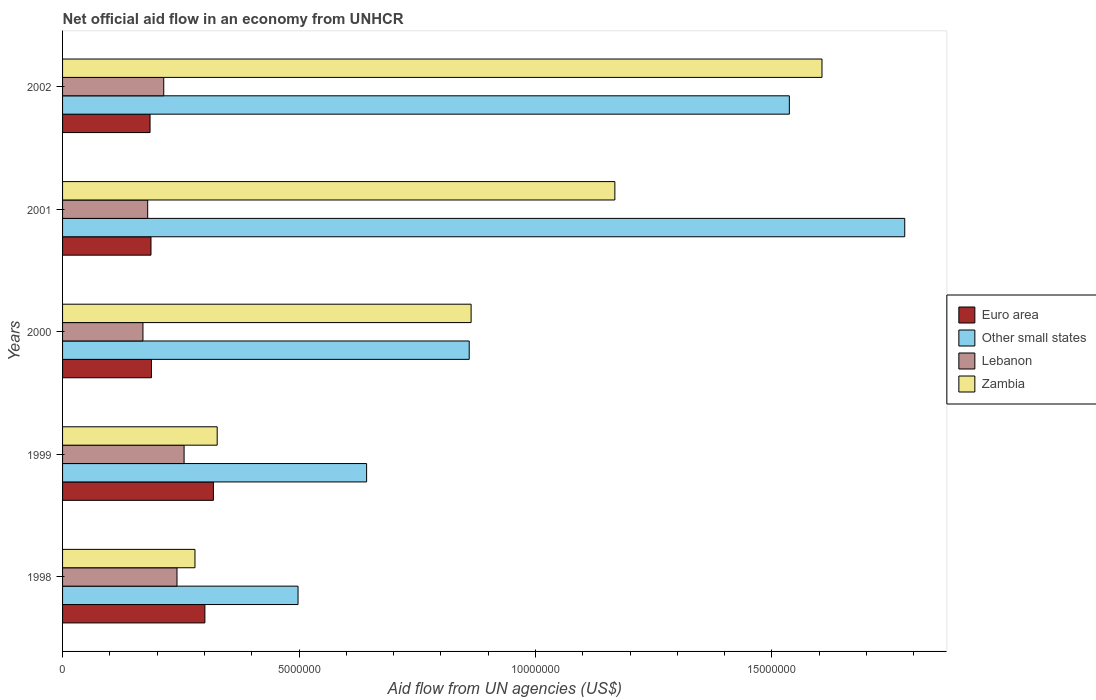Are the number of bars on each tick of the Y-axis equal?
Keep it short and to the point. Yes. How many bars are there on the 1st tick from the top?
Your answer should be compact. 4. How many bars are there on the 5th tick from the bottom?
Provide a short and direct response. 4. What is the label of the 5th group of bars from the top?
Offer a very short reply. 1998. In how many cases, is the number of bars for a given year not equal to the number of legend labels?
Offer a terse response. 0. What is the net official aid flow in Zambia in 2000?
Keep it short and to the point. 8.64e+06. Across all years, what is the maximum net official aid flow in Euro area?
Your response must be concise. 3.19e+06. Across all years, what is the minimum net official aid flow in Euro area?
Make the answer very short. 1.85e+06. In which year was the net official aid flow in Euro area maximum?
Provide a short and direct response. 1999. What is the total net official aid flow in Lebanon in the graph?
Make the answer very short. 1.06e+07. What is the difference between the net official aid flow in Zambia in 2001 and the net official aid flow in Lebanon in 1999?
Your response must be concise. 9.11e+06. What is the average net official aid flow in Zambia per year?
Ensure brevity in your answer.  8.49e+06. In the year 1999, what is the difference between the net official aid flow in Other small states and net official aid flow in Zambia?
Your answer should be compact. 3.16e+06. What is the ratio of the net official aid flow in Other small states in 2000 to that in 2001?
Keep it short and to the point. 0.48. Is the net official aid flow in Euro area in 2000 less than that in 2001?
Your answer should be compact. No. Is the difference between the net official aid flow in Other small states in 1999 and 2001 greater than the difference between the net official aid flow in Zambia in 1999 and 2001?
Provide a short and direct response. No. What is the difference between the highest and the second highest net official aid flow in Lebanon?
Your response must be concise. 1.50e+05. What is the difference between the highest and the lowest net official aid flow in Other small states?
Your answer should be compact. 1.28e+07. In how many years, is the net official aid flow in Other small states greater than the average net official aid flow in Other small states taken over all years?
Ensure brevity in your answer.  2. Is the sum of the net official aid flow in Euro area in 2000 and 2001 greater than the maximum net official aid flow in Zambia across all years?
Offer a terse response. No. Is it the case that in every year, the sum of the net official aid flow in Zambia and net official aid flow in Other small states is greater than the sum of net official aid flow in Lebanon and net official aid flow in Euro area?
Provide a succinct answer. No. What does the 1st bar from the top in 2002 represents?
Provide a short and direct response. Zambia. What does the 3rd bar from the bottom in 2001 represents?
Provide a short and direct response. Lebanon. Are all the bars in the graph horizontal?
Your response must be concise. Yes. What is the difference between two consecutive major ticks on the X-axis?
Give a very brief answer. 5.00e+06. Are the values on the major ticks of X-axis written in scientific E-notation?
Keep it short and to the point. No. Does the graph contain any zero values?
Provide a short and direct response. No. Does the graph contain grids?
Keep it short and to the point. No. Where does the legend appear in the graph?
Provide a short and direct response. Center right. How are the legend labels stacked?
Keep it short and to the point. Vertical. What is the title of the graph?
Offer a terse response. Net official aid flow in an economy from UNHCR. What is the label or title of the X-axis?
Give a very brief answer. Aid flow from UN agencies (US$). What is the label or title of the Y-axis?
Provide a short and direct response. Years. What is the Aid flow from UN agencies (US$) in Euro area in 1998?
Your answer should be very brief. 3.01e+06. What is the Aid flow from UN agencies (US$) in Other small states in 1998?
Make the answer very short. 4.98e+06. What is the Aid flow from UN agencies (US$) of Lebanon in 1998?
Offer a very short reply. 2.42e+06. What is the Aid flow from UN agencies (US$) in Zambia in 1998?
Your answer should be very brief. 2.80e+06. What is the Aid flow from UN agencies (US$) of Euro area in 1999?
Your answer should be very brief. 3.19e+06. What is the Aid flow from UN agencies (US$) in Other small states in 1999?
Give a very brief answer. 6.43e+06. What is the Aid flow from UN agencies (US$) of Lebanon in 1999?
Offer a very short reply. 2.57e+06. What is the Aid flow from UN agencies (US$) in Zambia in 1999?
Give a very brief answer. 3.27e+06. What is the Aid flow from UN agencies (US$) of Euro area in 2000?
Ensure brevity in your answer.  1.88e+06. What is the Aid flow from UN agencies (US$) in Other small states in 2000?
Offer a very short reply. 8.60e+06. What is the Aid flow from UN agencies (US$) in Lebanon in 2000?
Provide a succinct answer. 1.70e+06. What is the Aid flow from UN agencies (US$) in Zambia in 2000?
Keep it short and to the point. 8.64e+06. What is the Aid flow from UN agencies (US$) in Euro area in 2001?
Ensure brevity in your answer.  1.87e+06. What is the Aid flow from UN agencies (US$) of Other small states in 2001?
Provide a succinct answer. 1.78e+07. What is the Aid flow from UN agencies (US$) of Lebanon in 2001?
Your answer should be compact. 1.80e+06. What is the Aid flow from UN agencies (US$) in Zambia in 2001?
Provide a succinct answer. 1.17e+07. What is the Aid flow from UN agencies (US$) in Euro area in 2002?
Keep it short and to the point. 1.85e+06. What is the Aid flow from UN agencies (US$) in Other small states in 2002?
Your answer should be very brief. 1.54e+07. What is the Aid flow from UN agencies (US$) in Lebanon in 2002?
Your answer should be compact. 2.14e+06. What is the Aid flow from UN agencies (US$) of Zambia in 2002?
Offer a terse response. 1.61e+07. Across all years, what is the maximum Aid flow from UN agencies (US$) of Euro area?
Provide a succinct answer. 3.19e+06. Across all years, what is the maximum Aid flow from UN agencies (US$) of Other small states?
Your answer should be compact. 1.78e+07. Across all years, what is the maximum Aid flow from UN agencies (US$) in Lebanon?
Make the answer very short. 2.57e+06. Across all years, what is the maximum Aid flow from UN agencies (US$) in Zambia?
Ensure brevity in your answer.  1.61e+07. Across all years, what is the minimum Aid flow from UN agencies (US$) in Euro area?
Your answer should be very brief. 1.85e+06. Across all years, what is the minimum Aid flow from UN agencies (US$) in Other small states?
Your answer should be very brief. 4.98e+06. Across all years, what is the minimum Aid flow from UN agencies (US$) of Lebanon?
Give a very brief answer. 1.70e+06. Across all years, what is the minimum Aid flow from UN agencies (US$) in Zambia?
Make the answer very short. 2.80e+06. What is the total Aid flow from UN agencies (US$) in Euro area in the graph?
Make the answer very short. 1.18e+07. What is the total Aid flow from UN agencies (US$) of Other small states in the graph?
Offer a terse response. 5.32e+07. What is the total Aid flow from UN agencies (US$) of Lebanon in the graph?
Your answer should be compact. 1.06e+07. What is the total Aid flow from UN agencies (US$) of Zambia in the graph?
Offer a very short reply. 4.24e+07. What is the difference between the Aid flow from UN agencies (US$) of Euro area in 1998 and that in 1999?
Provide a short and direct response. -1.80e+05. What is the difference between the Aid flow from UN agencies (US$) of Other small states in 1998 and that in 1999?
Ensure brevity in your answer.  -1.45e+06. What is the difference between the Aid flow from UN agencies (US$) of Lebanon in 1998 and that in 1999?
Provide a short and direct response. -1.50e+05. What is the difference between the Aid flow from UN agencies (US$) in Zambia in 1998 and that in 1999?
Your answer should be compact. -4.70e+05. What is the difference between the Aid flow from UN agencies (US$) of Euro area in 1998 and that in 2000?
Offer a very short reply. 1.13e+06. What is the difference between the Aid flow from UN agencies (US$) in Other small states in 1998 and that in 2000?
Keep it short and to the point. -3.62e+06. What is the difference between the Aid flow from UN agencies (US$) in Lebanon in 1998 and that in 2000?
Your answer should be very brief. 7.20e+05. What is the difference between the Aid flow from UN agencies (US$) in Zambia in 1998 and that in 2000?
Offer a very short reply. -5.84e+06. What is the difference between the Aid flow from UN agencies (US$) in Euro area in 1998 and that in 2001?
Offer a terse response. 1.14e+06. What is the difference between the Aid flow from UN agencies (US$) of Other small states in 1998 and that in 2001?
Your response must be concise. -1.28e+07. What is the difference between the Aid flow from UN agencies (US$) of Lebanon in 1998 and that in 2001?
Your answer should be very brief. 6.20e+05. What is the difference between the Aid flow from UN agencies (US$) in Zambia in 1998 and that in 2001?
Give a very brief answer. -8.88e+06. What is the difference between the Aid flow from UN agencies (US$) in Euro area in 1998 and that in 2002?
Offer a very short reply. 1.16e+06. What is the difference between the Aid flow from UN agencies (US$) in Other small states in 1998 and that in 2002?
Provide a short and direct response. -1.04e+07. What is the difference between the Aid flow from UN agencies (US$) of Zambia in 1998 and that in 2002?
Offer a very short reply. -1.33e+07. What is the difference between the Aid flow from UN agencies (US$) of Euro area in 1999 and that in 2000?
Offer a very short reply. 1.31e+06. What is the difference between the Aid flow from UN agencies (US$) of Other small states in 1999 and that in 2000?
Keep it short and to the point. -2.17e+06. What is the difference between the Aid flow from UN agencies (US$) of Lebanon in 1999 and that in 2000?
Provide a short and direct response. 8.70e+05. What is the difference between the Aid flow from UN agencies (US$) in Zambia in 1999 and that in 2000?
Your response must be concise. -5.37e+06. What is the difference between the Aid flow from UN agencies (US$) of Euro area in 1999 and that in 2001?
Offer a very short reply. 1.32e+06. What is the difference between the Aid flow from UN agencies (US$) in Other small states in 1999 and that in 2001?
Provide a succinct answer. -1.14e+07. What is the difference between the Aid flow from UN agencies (US$) in Lebanon in 1999 and that in 2001?
Keep it short and to the point. 7.70e+05. What is the difference between the Aid flow from UN agencies (US$) of Zambia in 1999 and that in 2001?
Provide a succinct answer. -8.41e+06. What is the difference between the Aid flow from UN agencies (US$) in Euro area in 1999 and that in 2002?
Make the answer very short. 1.34e+06. What is the difference between the Aid flow from UN agencies (US$) of Other small states in 1999 and that in 2002?
Give a very brief answer. -8.94e+06. What is the difference between the Aid flow from UN agencies (US$) of Zambia in 1999 and that in 2002?
Your answer should be very brief. -1.28e+07. What is the difference between the Aid flow from UN agencies (US$) of Other small states in 2000 and that in 2001?
Give a very brief answer. -9.21e+06. What is the difference between the Aid flow from UN agencies (US$) in Lebanon in 2000 and that in 2001?
Give a very brief answer. -1.00e+05. What is the difference between the Aid flow from UN agencies (US$) of Zambia in 2000 and that in 2001?
Your answer should be compact. -3.04e+06. What is the difference between the Aid flow from UN agencies (US$) in Other small states in 2000 and that in 2002?
Your answer should be very brief. -6.77e+06. What is the difference between the Aid flow from UN agencies (US$) of Lebanon in 2000 and that in 2002?
Provide a short and direct response. -4.40e+05. What is the difference between the Aid flow from UN agencies (US$) in Zambia in 2000 and that in 2002?
Offer a terse response. -7.42e+06. What is the difference between the Aid flow from UN agencies (US$) in Other small states in 2001 and that in 2002?
Give a very brief answer. 2.44e+06. What is the difference between the Aid flow from UN agencies (US$) of Zambia in 2001 and that in 2002?
Your answer should be compact. -4.38e+06. What is the difference between the Aid flow from UN agencies (US$) in Euro area in 1998 and the Aid flow from UN agencies (US$) in Other small states in 1999?
Give a very brief answer. -3.42e+06. What is the difference between the Aid flow from UN agencies (US$) of Other small states in 1998 and the Aid flow from UN agencies (US$) of Lebanon in 1999?
Give a very brief answer. 2.41e+06. What is the difference between the Aid flow from UN agencies (US$) in Other small states in 1998 and the Aid flow from UN agencies (US$) in Zambia in 1999?
Provide a succinct answer. 1.71e+06. What is the difference between the Aid flow from UN agencies (US$) of Lebanon in 1998 and the Aid flow from UN agencies (US$) of Zambia in 1999?
Keep it short and to the point. -8.50e+05. What is the difference between the Aid flow from UN agencies (US$) in Euro area in 1998 and the Aid flow from UN agencies (US$) in Other small states in 2000?
Offer a terse response. -5.59e+06. What is the difference between the Aid flow from UN agencies (US$) of Euro area in 1998 and the Aid flow from UN agencies (US$) of Lebanon in 2000?
Give a very brief answer. 1.31e+06. What is the difference between the Aid flow from UN agencies (US$) of Euro area in 1998 and the Aid flow from UN agencies (US$) of Zambia in 2000?
Ensure brevity in your answer.  -5.63e+06. What is the difference between the Aid flow from UN agencies (US$) of Other small states in 1998 and the Aid flow from UN agencies (US$) of Lebanon in 2000?
Provide a short and direct response. 3.28e+06. What is the difference between the Aid flow from UN agencies (US$) of Other small states in 1998 and the Aid flow from UN agencies (US$) of Zambia in 2000?
Offer a terse response. -3.66e+06. What is the difference between the Aid flow from UN agencies (US$) of Lebanon in 1998 and the Aid flow from UN agencies (US$) of Zambia in 2000?
Your answer should be very brief. -6.22e+06. What is the difference between the Aid flow from UN agencies (US$) of Euro area in 1998 and the Aid flow from UN agencies (US$) of Other small states in 2001?
Keep it short and to the point. -1.48e+07. What is the difference between the Aid flow from UN agencies (US$) of Euro area in 1998 and the Aid flow from UN agencies (US$) of Lebanon in 2001?
Make the answer very short. 1.21e+06. What is the difference between the Aid flow from UN agencies (US$) in Euro area in 1998 and the Aid flow from UN agencies (US$) in Zambia in 2001?
Make the answer very short. -8.67e+06. What is the difference between the Aid flow from UN agencies (US$) of Other small states in 1998 and the Aid flow from UN agencies (US$) of Lebanon in 2001?
Provide a succinct answer. 3.18e+06. What is the difference between the Aid flow from UN agencies (US$) of Other small states in 1998 and the Aid flow from UN agencies (US$) of Zambia in 2001?
Your answer should be compact. -6.70e+06. What is the difference between the Aid flow from UN agencies (US$) in Lebanon in 1998 and the Aid flow from UN agencies (US$) in Zambia in 2001?
Ensure brevity in your answer.  -9.26e+06. What is the difference between the Aid flow from UN agencies (US$) of Euro area in 1998 and the Aid flow from UN agencies (US$) of Other small states in 2002?
Your answer should be compact. -1.24e+07. What is the difference between the Aid flow from UN agencies (US$) in Euro area in 1998 and the Aid flow from UN agencies (US$) in Lebanon in 2002?
Offer a very short reply. 8.70e+05. What is the difference between the Aid flow from UN agencies (US$) in Euro area in 1998 and the Aid flow from UN agencies (US$) in Zambia in 2002?
Provide a succinct answer. -1.30e+07. What is the difference between the Aid flow from UN agencies (US$) in Other small states in 1998 and the Aid flow from UN agencies (US$) in Lebanon in 2002?
Your answer should be compact. 2.84e+06. What is the difference between the Aid flow from UN agencies (US$) of Other small states in 1998 and the Aid flow from UN agencies (US$) of Zambia in 2002?
Give a very brief answer. -1.11e+07. What is the difference between the Aid flow from UN agencies (US$) in Lebanon in 1998 and the Aid flow from UN agencies (US$) in Zambia in 2002?
Give a very brief answer. -1.36e+07. What is the difference between the Aid flow from UN agencies (US$) in Euro area in 1999 and the Aid flow from UN agencies (US$) in Other small states in 2000?
Keep it short and to the point. -5.41e+06. What is the difference between the Aid flow from UN agencies (US$) of Euro area in 1999 and the Aid flow from UN agencies (US$) of Lebanon in 2000?
Offer a terse response. 1.49e+06. What is the difference between the Aid flow from UN agencies (US$) of Euro area in 1999 and the Aid flow from UN agencies (US$) of Zambia in 2000?
Keep it short and to the point. -5.45e+06. What is the difference between the Aid flow from UN agencies (US$) in Other small states in 1999 and the Aid flow from UN agencies (US$) in Lebanon in 2000?
Your answer should be compact. 4.73e+06. What is the difference between the Aid flow from UN agencies (US$) of Other small states in 1999 and the Aid flow from UN agencies (US$) of Zambia in 2000?
Your response must be concise. -2.21e+06. What is the difference between the Aid flow from UN agencies (US$) of Lebanon in 1999 and the Aid flow from UN agencies (US$) of Zambia in 2000?
Provide a succinct answer. -6.07e+06. What is the difference between the Aid flow from UN agencies (US$) of Euro area in 1999 and the Aid flow from UN agencies (US$) of Other small states in 2001?
Offer a very short reply. -1.46e+07. What is the difference between the Aid flow from UN agencies (US$) in Euro area in 1999 and the Aid flow from UN agencies (US$) in Lebanon in 2001?
Keep it short and to the point. 1.39e+06. What is the difference between the Aid flow from UN agencies (US$) of Euro area in 1999 and the Aid flow from UN agencies (US$) of Zambia in 2001?
Offer a terse response. -8.49e+06. What is the difference between the Aid flow from UN agencies (US$) in Other small states in 1999 and the Aid flow from UN agencies (US$) in Lebanon in 2001?
Your answer should be compact. 4.63e+06. What is the difference between the Aid flow from UN agencies (US$) in Other small states in 1999 and the Aid flow from UN agencies (US$) in Zambia in 2001?
Offer a very short reply. -5.25e+06. What is the difference between the Aid flow from UN agencies (US$) of Lebanon in 1999 and the Aid flow from UN agencies (US$) of Zambia in 2001?
Your response must be concise. -9.11e+06. What is the difference between the Aid flow from UN agencies (US$) in Euro area in 1999 and the Aid flow from UN agencies (US$) in Other small states in 2002?
Your response must be concise. -1.22e+07. What is the difference between the Aid flow from UN agencies (US$) in Euro area in 1999 and the Aid flow from UN agencies (US$) in Lebanon in 2002?
Offer a very short reply. 1.05e+06. What is the difference between the Aid flow from UN agencies (US$) in Euro area in 1999 and the Aid flow from UN agencies (US$) in Zambia in 2002?
Offer a very short reply. -1.29e+07. What is the difference between the Aid flow from UN agencies (US$) of Other small states in 1999 and the Aid flow from UN agencies (US$) of Lebanon in 2002?
Give a very brief answer. 4.29e+06. What is the difference between the Aid flow from UN agencies (US$) in Other small states in 1999 and the Aid flow from UN agencies (US$) in Zambia in 2002?
Offer a very short reply. -9.63e+06. What is the difference between the Aid flow from UN agencies (US$) of Lebanon in 1999 and the Aid flow from UN agencies (US$) of Zambia in 2002?
Keep it short and to the point. -1.35e+07. What is the difference between the Aid flow from UN agencies (US$) of Euro area in 2000 and the Aid flow from UN agencies (US$) of Other small states in 2001?
Your response must be concise. -1.59e+07. What is the difference between the Aid flow from UN agencies (US$) in Euro area in 2000 and the Aid flow from UN agencies (US$) in Zambia in 2001?
Offer a very short reply. -9.80e+06. What is the difference between the Aid flow from UN agencies (US$) of Other small states in 2000 and the Aid flow from UN agencies (US$) of Lebanon in 2001?
Ensure brevity in your answer.  6.80e+06. What is the difference between the Aid flow from UN agencies (US$) in Other small states in 2000 and the Aid flow from UN agencies (US$) in Zambia in 2001?
Provide a short and direct response. -3.08e+06. What is the difference between the Aid flow from UN agencies (US$) of Lebanon in 2000 and the Aid flow from UN agencies (US$) of Zambia in 2001?
Your response must be concise. -9.98e+06. What is the difference between the Aid flow from UN agencies (US$) of Euro area in 2000 and the Aid flow from UN agencies (US$) of Other small states in 2002?
Your answer should be very brief. -1.35e+07. What is the difference between the Aid flow from UN agencies (US$) in Euro area in 2000 and the Aid flow from UN agencies (US$) in Zambia in 2002?
Ensure brevity in your answer.  -1.42e+07. What is the difference between the Aid flow from UN agencies (US$) of Other small states in 2000 and the Aid flow from UN agencies (US$) of Lebanon in 2002?
Make the answer very short. 6.46e+06. What is the difference between the Aid flow from UN agencies (US$) in Other small states in 2000 and the Aid flow from UN agencies (US$) in Zambia in 2002?
Offer a terse response. -7.46e+06. What is the difference between the Aid flow from UN agencies (US$) in Lebanon in 2000 and the Aid flow from UN agencies (US$) in Zambia in 2002?
Give a very brief answer. -1.44e+07. What is the difference between the Aid flow from UN agencies (US$) in Euro area in 2001 and the Aid flow from UN agencies (US$) in Other small states in 2002?
Provide a succinct answer. -1.35e+07. What is the difference between the Aid flow from UN agencies (US$) in Euro area in 2001 and the Aid flow from UN agencies (US$) in Zambia in 2002?
Your answer should be very brief. -1.42e+07. What is the difference between the Aid flow from UN agencies (US$) of Other small states in 2001 and the Aid flow from UN agencies (US$) of Lebanon in 2002?
Your response must be concise. 1.57e+07. What is the difference between the Aid flow from UN agencies (US$) in Other small states in 2001 and the Aid flow from UN agencies (US$) in Zambia in 2002?
Your answer should be very brief. 1.75e+06. What is the difference between the Aid flow from UN agencies (US$) in Lebanon in 2001 and the Aid flow from UN agencies (US$) in Zambia in 2002?
Make the answer very short. -1.43e+07. What is the average Aid flow from UN agencies (US$) of Euro area per year?
Ensure brevity in your answer.  2.36e+06. What is the average Aid flow from UN agencies (US$) in Other small states per year?
Provide a succinct answer. 1.06e+07. What is the average Aid flow from UN agencies (US$) in Lebanon per year?
Give a very brief answer. 2.13e+06. What is the average Aid flow from UN agencies (US$) in Zambia per year?
Your answer should be very brief. 8.49e+06. In the year 1998, what is the difference between the Aid flow from UN agencies (US$) in Euro area and Aid flow from UN agencies (US$) in Other small states?
Your response must be concise. -1.97e+06. In the year 1998, what is the difference between the Aid flow from UN agencies (US$) in Euro area and Aid flow from UN agencies (US$) in Lebanon?
Provide a short and direct response. 5.90e+05. In the year 1998, what is the difference between the Aid flow from UN agencies (US$) of Euro area and Aid flow from UN agencies (US$) of Zambia?
Offer a terse response. 2.10e+05. In the year 1998, what is the difference between the Aid flow from UN agencies (US$) in Other small states and Aid flow from UN agencies (US$) in Lebanon?
Your answer should be compact. 2.56e+06. In the year 1998, what is the difference between the Aid flow from UN agencies (US$) in Other small states and Aid flow from UN agencies (US$) in Zambia?
Your answer should be compact. 2.18e+06. In the year 1998, what is the difference between the Aid flow from UN agencies (US$) of Lebanon and Aid flow from UN agencies (US$) of Zambia?
Provide a short and direct response. -3.80e+05. In the year 1999, what is the difference between the Aid flow from UN agencies (US$) of Euro area and Aid flow from UN agencies (US$) of Other small states?
Keep it short and to the point. -3.24e+06. In the year 1999, what is the difference between the Aid flow from UN agencies (US$) in Euro area and Aid flow from UN agencies (US$) in Lebanon?
Ensure brevity in your answer.  6.20e+05. In the year 1999, what is the difference between the Aid flow from UN agencies (US$) of Euro area and Aid flow from UN agencies (US$) of Zambia?
Offer a very short reply. -8.00e+04. In the year 1999, what is the difference between the Aid flow from UN agencies (US$) in Other small states and Aid flow from UN agencies (US$) in Lebanon?
Your response must be concise. 3.86e+06. In the year 1999, what is the difference between the Aid flow from UN agencies (US$) of Other small states and Aid flow from UN agencies (US$) of Zambia?
Offer a very short reply. 3.16e+06. In the year 1999, what is the difference between the Aid flow from UN agencies (US$) of Lebanon and Aid flow from UN agencies (US$) of Zambia?
Offer a very short reply. -7.00e+05. In the year 2000, what is the difference between the Aid flow from UN agencies (US$) of Euro area and Aid flow from UN agencies (US$) of Other small states?
Offer a very short reply. -6.72e+06. In the year 2000, what is the difference between the Aid flow from UN agencies (US$) in Euro area and Aid flow from UN agencies (US$) in Zambia?
Keep it short and to the point. -6.76e+06. In the year 2000, what is the difference between the Aid flow from UN agencies (US$) in Other small states and Aid flow from UN agencies (US$) in Lebanon?
Your answer should be very brief. 6.90e+06. In the year 2000, what is the difference between the Aid flow from UN agencies (US$) in Other small states and Aid flow from UN agencies (US$) in Zambia?
Provide a succinct answer. -4.00e+04. In the year 2000, what is the difference between the Aid flow from UN agencies (US$) of Lebanon and Aid flow from UN agencies (US$) of Zambia?
Provide a succinct answer. -6.94e+06. In the year 2001, what is the difference between the Aid flow from UN agencies (US$) of Euro area and Aid flow from UN agencies (US$) of Other small states?
Ensure brevity in your answer.  -1.59e+07. In the year 2001, what is the difference between the Aid flow from UN agencies (US$) in Euro area and Aid flow from UN agencies (US$) in Lebanon?
Your response must be concise. 7.00e+04. In the year 2001, what is the difference between the Aid flow from UN agencies (US$) of Euro area and Aid flow from UN agencies (US$) of Zambia?
Offer a very short reply. -9.81e+06. In the year 2001, what is the difference between the Aid flow from UN agencies (US$) of Other small states and Aid flow from UN agencies (US$) of Lebanon?
Offer a very short reply. 1.60e+07. In the year 2001, what is the difference between the Aid flow from UN agencies (US$) of Other small states and Aid flow from UN agencies (US$) of Zambia?
Make the answer very short. 6.13e+06. In the year 2001, what is the difference between the Aid flow from UN agencies (US$) in Lebanon and Aid flow from UN agencies (US$) in Zambia?
Your response must be concise. -9.88e+06. In the year 2002, what is the difference between the Aid flow from UN agencies (US$) of Euro area and Aid flow from UN agencies (US$) of Other small states?
Your response must be concise. -1.35e+07. In the year 2002, what is the difference between the Aid flow from UN agencies (US$) of Euro area and Aid flow from UN agencies (US$) of Zambia?
Provide a short and direct response. -1.42e+07. In the year 2002, what is the difference between the Aid flow from UN agencies (US$) of Other small states and Aid flow from UN agencies (US$) of Lebanon?
Provide a short and direct response. 1.32e+07. In the year 2002, what is the difference between the Aid flow from UN agencies (US$) of Other small states and Aid flow from UN agencies (US$) of Zambia?
Provide a short and direct response. -6.90e+05. In the year 2002, what is the difference between the Aid flow from UN agencies (US$) of Lebanon and Aid flow from UN agencies (US$) of Zambia?
Provide a short and direct response. -1.39e+07. What is the ratio of the Aid flow from UN agencies (US$) of Euro area in 1998 to that in 1999?
Make the answer very short. 0.94. What is the ratio of the Aid flow from UN agencies (US$) in Other small states in 1998 to that in 1999?
Your response must be concise. 0.77. What is the ratio of the Aid flow from UN agencies (US$) of Lebanon in 1998 to that in 1999?
Provide a short and direct response. 0.94. What is the ratio of the Aid flow from UN agencies (US$) of Zambia in 1998 to that in 1999?
Offer a very short reply. 0.86. What is the ratio of the Aid flow from UN agencies (US$) of Euro area in 1998 to that in 2000?
Keep it short and to the point. 1.6. What is the ratio of the Aid flow from UN agencies (US$) in Other small states in 1998 to that in 2000?
Offer a very short reply. 0.58. What is the ratio of the Aid flow from UN agencies (US$) of Lebanon in 1998 to that in 2000?
Give a very brief answer. 1.42. What is the ratio of the Aid flow from UN agencies (US$) of Zambia in 1998 to that in 2000?
Your response must be concise. 0.32. What is the ratio of the Aid flow from UN agencies (US$) in Euro area in 1998 to that in 2001?
Give a very brief answer. 1.61. What is the ratio of the Aid flow from UN agencies (US$) of Other small states in 1998 to that in 2001?
Offer a terse response. 0.28. What is the ratio of the Aid flow from UN agencies (US$) in Lebanon in 1998 to that in 2001?
Offer a very short reply. 1.34. What is the ratio of the Aid flow from UN agencies (US$) of Zambia in 1998 to that in 2001?
Your answer should be compact. 0.24. What is the ratio of the Aid flow from UN agencies (US$) in Euro area in 1998 to that in 2002?
Your answer should be compact. 1.63. What is the ratio of the Aid flow from UN agencies (US$) in Other small states in 1998 to that in 2002?
Your response must be concise. 0.32. What is the ratio of the Aid flow from UN agencies (US$) of Lebanon in 1998 to that in 2002?
Your answer should be very brief. 1.13. What is the ratio of the Aid flow from UN agencies (US$) in Zambia in 1998 to that in 2002?
Your answer should be very brief. 0.17. What is the ratio of the Aid flow from UN agencies (US$) of Euro area in 1999 to that in 2000?
Your response must be concise. 1.7. What is the ratio of the Aid flow from UN agencies (US$) in Other small states in 1999 to that in 2000?
Keep it short and to the point. 0.75. What is the ratio of the Aid flow from UN agencies (US$) of Lebanon in 1999 to that in 2000?
Give a very brief answer. 1.51. What is the ratio of the Aid flow from UN agencies (US$) of Zambia in 1999 to that in 2000?
Keep it short and to the point. 0.38. What is the ratio of the Aid flow from UN agencies (US$) in Euro area in 1999 to that in 2001?
Your response must be concise. 1.71. What is the ratio of the Aid flow from UN agencies (US$) of Other small states in 1999 to that in 2001?
Your response must be concise. 0.36. What is the ratio of the Aid flow from UN agencies (US$) of Lebanon in 1999 to that in 2001?
Ensure brevity in your answer.  1.43. What is the ratio of the Aid flow from UN agencies (US$) in Zambia in 1999 to that in 2001?
Keep it short and to the point. 0.28. What is the ratio of the Aid flow from UN agencies (US$) of Euro area in 1999 to that in 2002?
Keep it short and to the point. 1.72. What is the ratio of the Aid flow from UN agencies (US$) in Other small states in 1999 to that in 2002?
Your answer should be very brief. 0.42. What is the ratio of the Aid flow from UN agencies (US$) of Lebanon in 1999 to that in 2002?
Your answer should be very brief. 1.2. What is the ratio of the Aid flow from UN agencies (US$) in Zambia in 1999 to that in 2002?
Offer a terse response. 0.2. What is the ratio of the Aid flow from UN agencies (US$) of Euro area in 2000 to that in 2001?
Provide a succinct answer. 1.01. What is the ratio of the Aid flow from UN agencies (US$) of Other small states in 2000 to that in 2001?
Your answer should be very brief. 0.48. What is the ratio of the Aid flow from UN agencies (US$) in Zambia in 2000 to that in 2001?
Provide a succinct answer. 0.74. What is the ratio of the Aid flow from UN agencies (US$) of Euro area in 2000 to that in 2002?
Provide a short and direct response. 1.02. What is the ratio of the Aid flow from UN agencies (US$) in Other small states in 2000 to that in 2002?
Provide a short and direct response. 0.56. What is the ratio of the Aid flow from UN agencies (US$) of Lebanon in 2000 to that in 2002?
Offer a terse response. 0.79. What is the ratio of the Aid flow from UN agencies (US$) in Zambia in 2000 to that in 2002?
Your answer should be very brief. 0.54. What is the ratio of the Aid flow from UN agencies (US$) of Euro area in 2001 to that in 2002?
Provide a succinct answer. 1.01. What is the ratio of the Aid flow from UN agencies (US$) of Other small states in 2001 to that in 2002?
Keep it short and to the point. 1.16. What is the ratio of the Aid flow from UN agencies (US$) in Lebanon in 2001 to that in 2002?
Make the answer very short. 0.84. What is the ratio of the Aid flow from UN agencies (US$) of Zambia in 2001 to that in 2002?
Your response must be concise. 0.73. What is the difference between the highest and the second highest Aid flow from UN agencies (US$) of Euro area?
Your response must be concise. 1.80e+05. What is the difference between the highest and the second highest Aid flow from UN agencies (US$) of Other small states?
Make the answer very short. 2.44e+06. What is the difference between the highest and the second highest Aid flow from UN agencies (US$) of Lebanon?
Make the answer very short. 1.50e+05. What is the difference between the highest and the second highest Aid flow from UN agencies (US$) of Zambia?
Ensure brevity in your answer.  4.38e+06. What is the difference between the highest and the lowest Aid flow from UN agencies (US$) in Euro area?
Provide a short and direct response. 1.34e+06. What is the difference between the highest and the lowest Aid flow from UN agencies (US$) in Other small states?
Offer a very short reply. 1.28e+07. What is the difference between the highest and the lowest Aid flow from UN agencies (US$) of Lebanon?
Your response must be concise. 8.70e+05. What is the difference between the highest and the lowest Aid flow from UN agencies (US$) of Zambia?
Provide a succinct answer. 1.33e+07. 